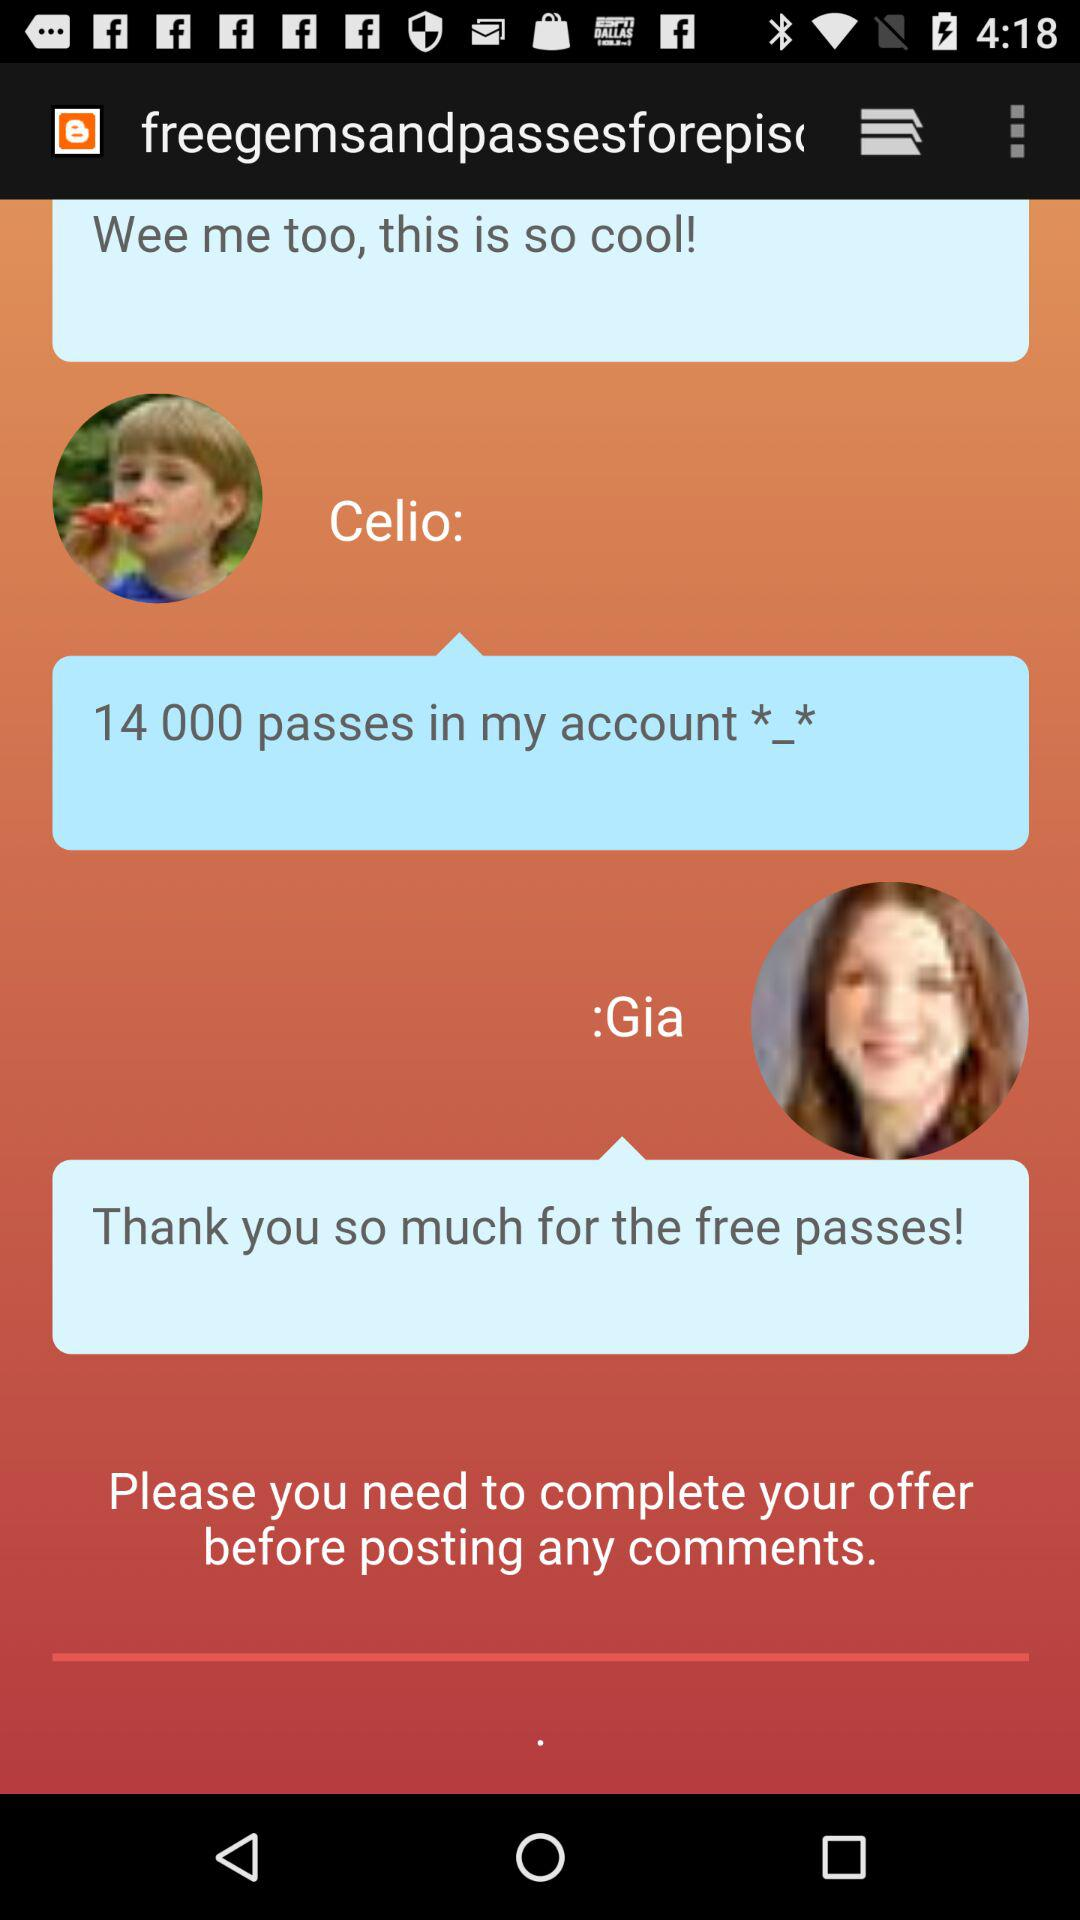How many passes are there in Celio's account? There are 14,000 passes. 